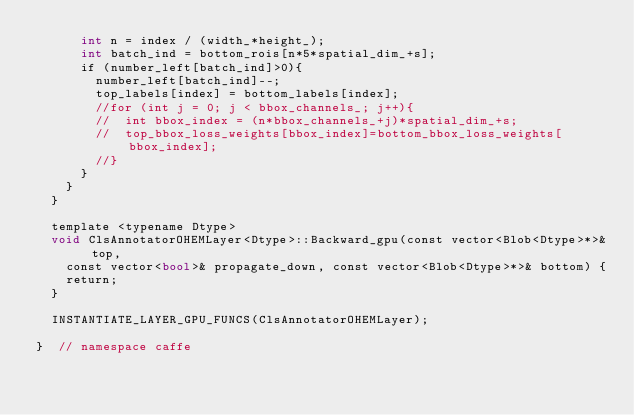Convert code to text. <code><loc_0><loc_0><loc_500><loc_500><_Cuda_>      int n = index / (width_*height_);
      int batch_ind = bottom_rois[n*5*spatial_dim_+s];
      if (number_left[batch_ind]>0){
        number_left[batch_ind]--;
        top_labels[index] = bottom_labels[index];
        //for (int j = 0; j < bbox_channels_; j++){
        //  int bbox_index = (n*bbox_channels_+j)*spatial_dim_+s;
        //  top_bbox_loss_weights[bbox_index]=bottom_bbox_loss_weights[bbox_index];
        //}
      }
    }
  }

  template <typename Dtype>
  void ClsAnnotatorOHEMLayer<Dtype>::Backward_gpu(const vector<Blob<Dtype>*>& top,
    const vector<bool>& propagate_down, const vector<Blob<Dtype>*>& bottom) {
    return;
  }

  INSTANTIATE_LAYER_GPU_FUNCS(ClsAnnotatorOHEMLayer);

}  // namespace caffe
</code> 